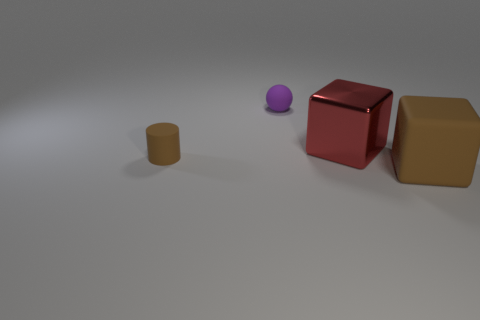The other thing that is the same shape as the red metal object is what size?
Give a very brief answer. Large. What number of cylinders have the same material as the tiny purple ball?
Provide a short and direct response. 1. How many tiny rubber objects are the same color as the matte cube?
Make the answer very short. 1. How many things are either blocks behind the brown matte cylinder or matte objects that are in front of the large red block?
Make the answer very short. 3. Is the number of large rubber things that are to the left of the purple rubber thing less than the number of brown matte objects?
Make the answer very short. Yes. Is there a brown thing that has the same size as the purple sphere?
Keep it short and to the point. Yes. What color is the cylinder?
Provide a succinct answer. Brown. Do the brown rubber block and the red metallic thing have the same size?
Offer a very short reply. Yes. What number of things are brown metal things or brown rubber objects?
Your response must be concise. 2. Is the number of rubber cylinders behind the red object the same as the number of spheres?
Your answer should be very brief. No. 